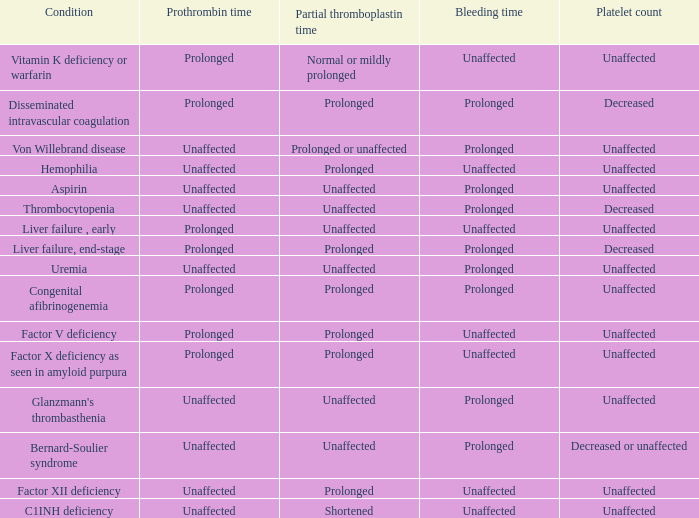Which Bleeding has a Condition of congenital afibrinogenemia? Prolonged. 